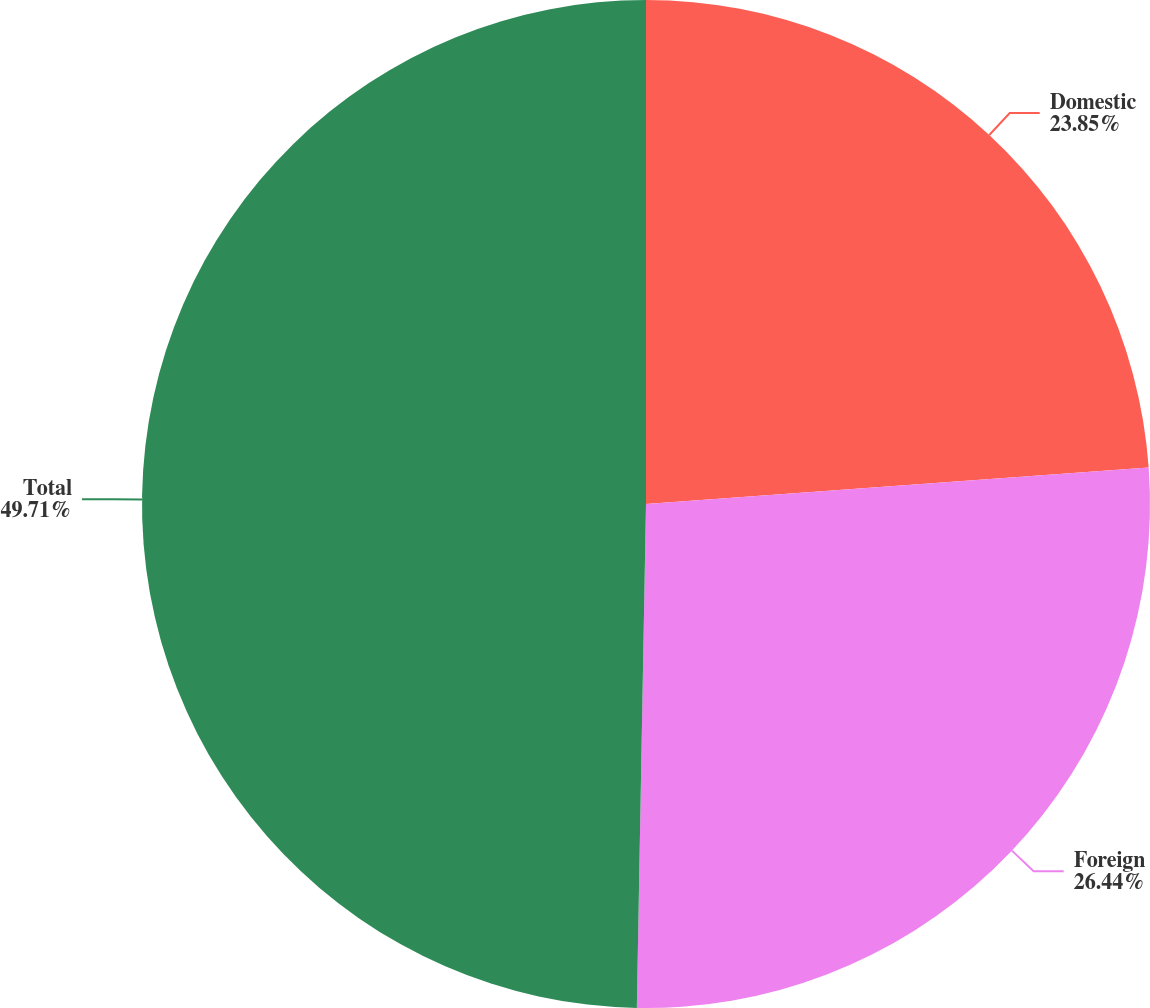Convert chart. <chart><loc_0><loc_0><loc_500><loc_500><pie_chart><fcel>Domestic<fcel>Foreign<fcel>Total<nl><fcel>23.85%<fcel>26.44%<fcel>49.71%<nl></chart> 